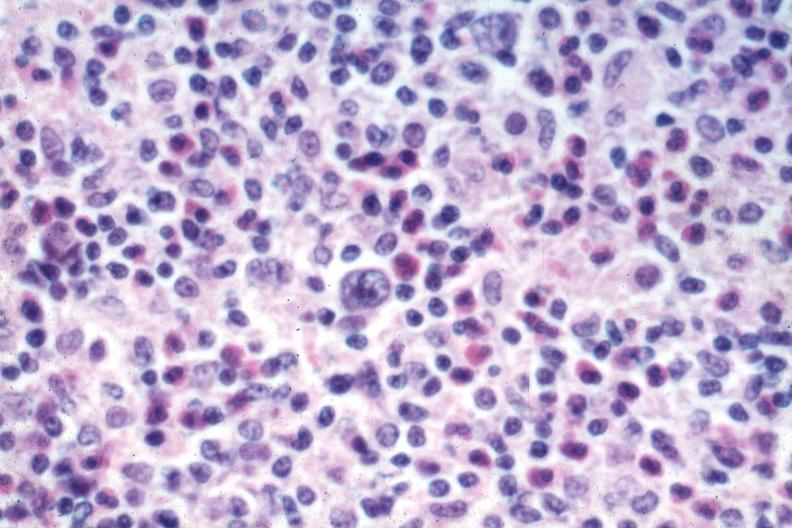what is present?
Answer the question using a single word or phrase. Lymph node 